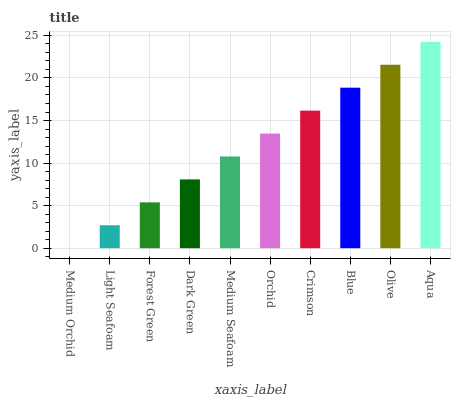Is Light Seafoam the minimum?
Answer yes or no. No. Is Light Seafoam the maximum?
Answer yes or no. No. Is Light Seafoam greater than Medium Orchid?
Answer yes or no. Yes. Is Medium Orchid less than Light Seafoam?
Answer yes or no. Yes. Is Medium Orchid greater than Light Seafoam?
Answer yes or no. No. Is Light Seafoam less than Medium Orchid?
Answer yes or no. No. Is Orchid the high median?
Answer yes or no. Yes. Is Medium Seafoam the low median?
Answer yes or no. Yes. Is Forest Green the high median?
Answer yes or no. No. Is Orchid the low median?
Answer yes or no. No. 